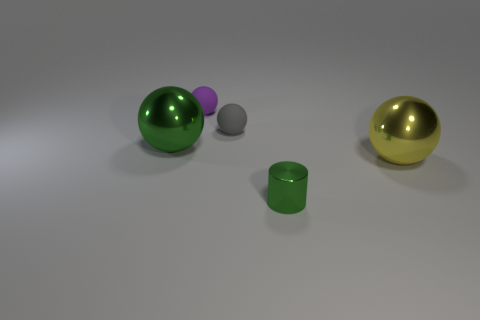Subtract all small purple spheres. How many spheres are left? 3 Add 3 large green things. How many objects exist? 8 Subtract all gray balls. How many balls are left? 3 Subtract all cylinders. How many objects are left? 4 Subtract all gray cubes. How many purple cylinders are left? 0 Subtract all yellow shiny things. Subtract all red rubber spheres. How many objects are left? 4 Add 1 large green spheres. How many large green spheres are left? 2 Add 3 tiny purple shiny balls. How many tiny purple shiny balls exist? 3 Subtract 0 blue cylinders. How many objects are left? 5 Subtract all yellow cylinders. Subtract all brown spheres. How many cylinders are left? 1 